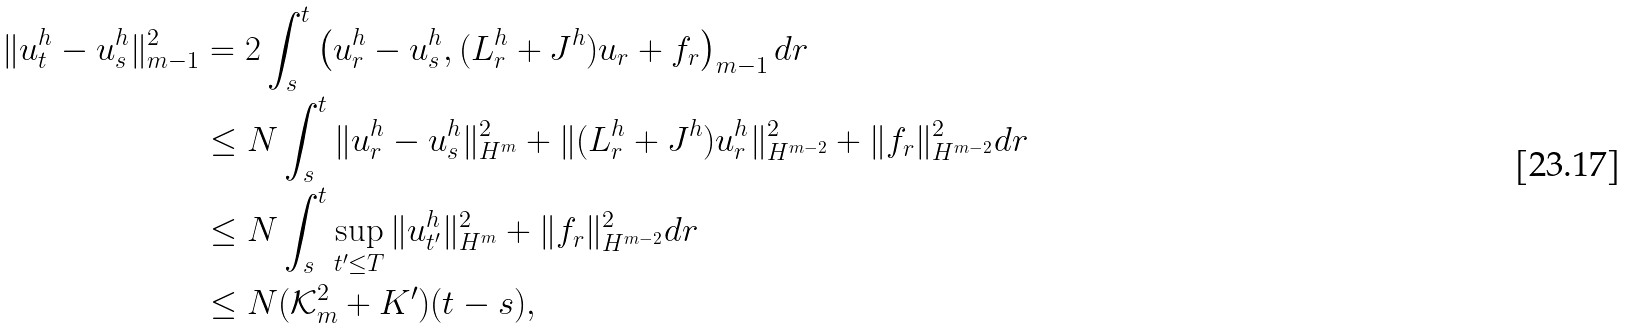<formula> <loc_0><loc_0><loc_500><loc_500>\| u ^ { h } _ { t } - u ^ { h } _ { s } \| ^ { 2 } _ { m - 1 } & = 2 \int _ { s } ^ { t } \left ( u ^ { h } _ { r } - u ^ { h } _ { s } , ( L ^ { h } _ { r } + J ^ { h } ) u _ { r } + f _ { r } \right ) _ { m - 1 } d r \\ & \leq N \int _ { s } ^ { t } \| u ^ { h } _ { r } - u ^ { h } _ { s } \| ^ { 2 } _ { H ^ { m } } + \| ( L ^ { h } _ { r } + J ^ { h } ) u ^ { h } _ { r } \| ^ { 2 } _ { H ^ { m - 2 } } + \| f _ { r } \| ^ { 2 } _ { H ^ { m - 2 } } d r \\ & \leq N \int _ { s } ^ { t } \sup _ { t ^ { \prime } \leq T } \| u ^ { h } _ { t ^ { \prime } } \| ^ { 2 } _ { H ^ { m } } + \| f _ { r } \| ^ { 2 } _ { H ^ { m - 2 } } d r \\ & \leq N ( \mathcal { K } _ { m } ^ { 2 } + K ^ { \prime } ) ( t - s ) ,</formula> 